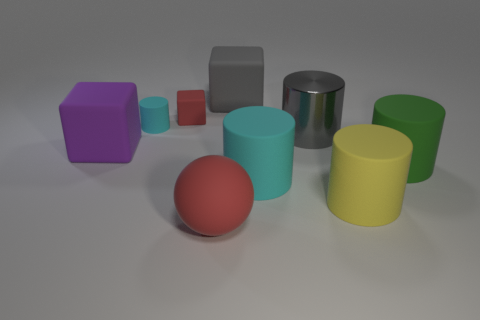There is a cylinder that is behind the big gray object on the right side of the large gray block; is there a cyan rubber cylinder on the right side of it?
Make the answer very short. Yes. What shape is the big thing that is on the left side of the large gray cube and behind the large red ball?
Make the answer very short. Cube. Is there a matte cube of the same color as the big metal object?
Your answer should be very brief. Yes. There is a big rubber block left of the big matte sphere that is in front of the tiny red matte object; what is its color?
Your answer should be very brief. Purple. There is a red thing in front of the rubber cube that is in front of the big cylinder that is behind the large green matte object; how big is it?
Offer a very short reply. Large. Is the large gray block made of the same material as the big cylinder behind the green rubber thing?
Offer a very short reply. No. The red block that is made of the same material as the big gray cube is what size?
Provide a short and direct response. Small. Is there a large purple object that has the same shape as the big gray matte thing?
Provide a succinct answer. Yes. What number of things are either matte cylinders right of the big matte sphere or large cyan cylinders?
Ensure brevity in your answer.  3. There is another rubber cylinder that is the same color as the small cylinder; what is its size?
Offer a terse response. Large. 